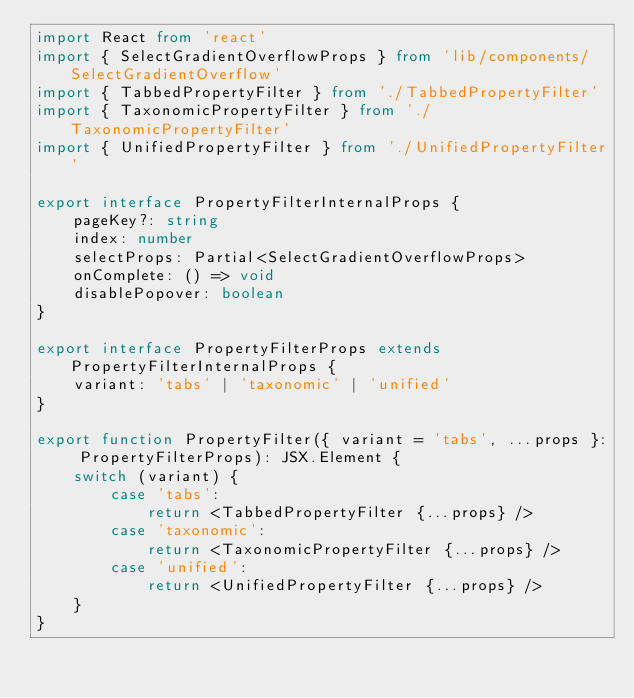Convert code to text. <code><loc_0><loc_0><loc_500><loc_500><_TypeScript_>import React from 'react'
import { SelectGradientOverflowProps } from 'lib/components/SelectGradientOverflow'
import { TabbedPropertyFilter } from './TabbedPropertyFilter'
import { TaxonomicPropertyFilter } from './TaxonomicPropertyFilter'
import { UnifiedPropertyFilter } from './UnifiedPropertyFilter'

export interface PropertyFilterInternalProps {
    pageKey?: string
    index: number
    selectProps: Partial<SelectGradientOverflowProps>
    onComplete: () => void
    disablePopover: boolean
}

export interface PropertyFilterProps extends PropertyFilterInternalProps {
    variant: 'tabs' | 'taxonomic' | 'unified'
}

export function PropertyFilter({ variant = 'tabs', ...props }: PropertyFilterProps): JSX.Element {
    switch (variant) {
        case 'tabs':
            return <TabbedPropertyFilter {...props} />
        case 'taxonomic':
            return <TaxonomicPropertyFilter {...props} />
        case 'unified':
            return <UnifiedPropertyFilter {...props} />
    }
}
</code> 